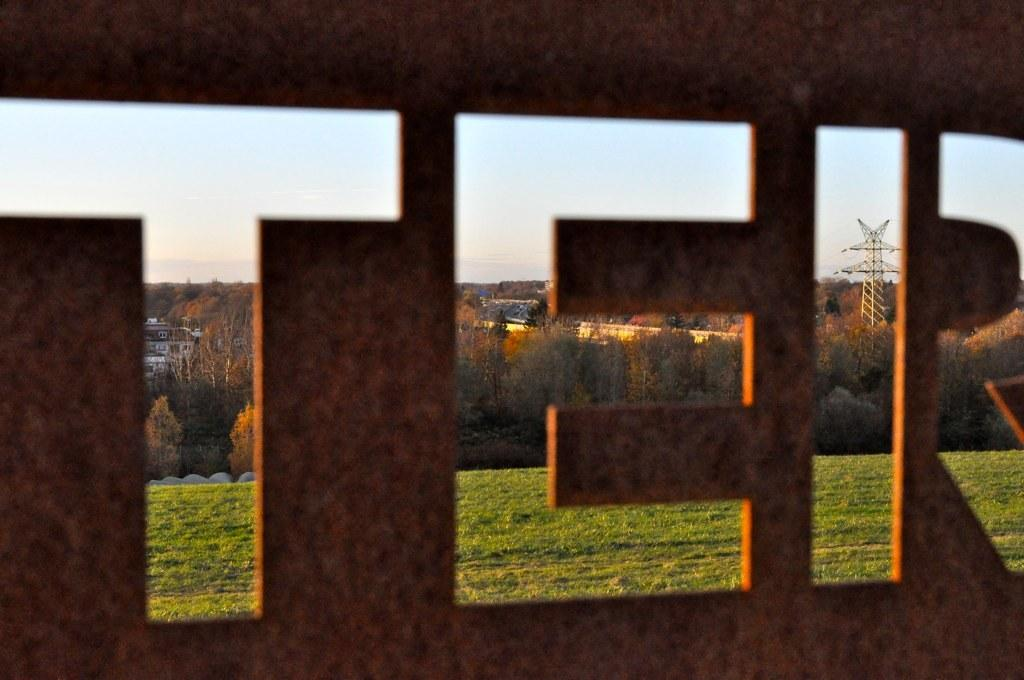What type of structure can be seen in the image? There is a fencing in the image. What can be seen through the fencing? Grass, trees, poles, buildings, and the sky are visible through the fencing. What type of degree is being awarded to the person in the image? There is no person present in the image, and therefore no degree being awarded. Can you see a tub in the image? There is no tub present in the image. 